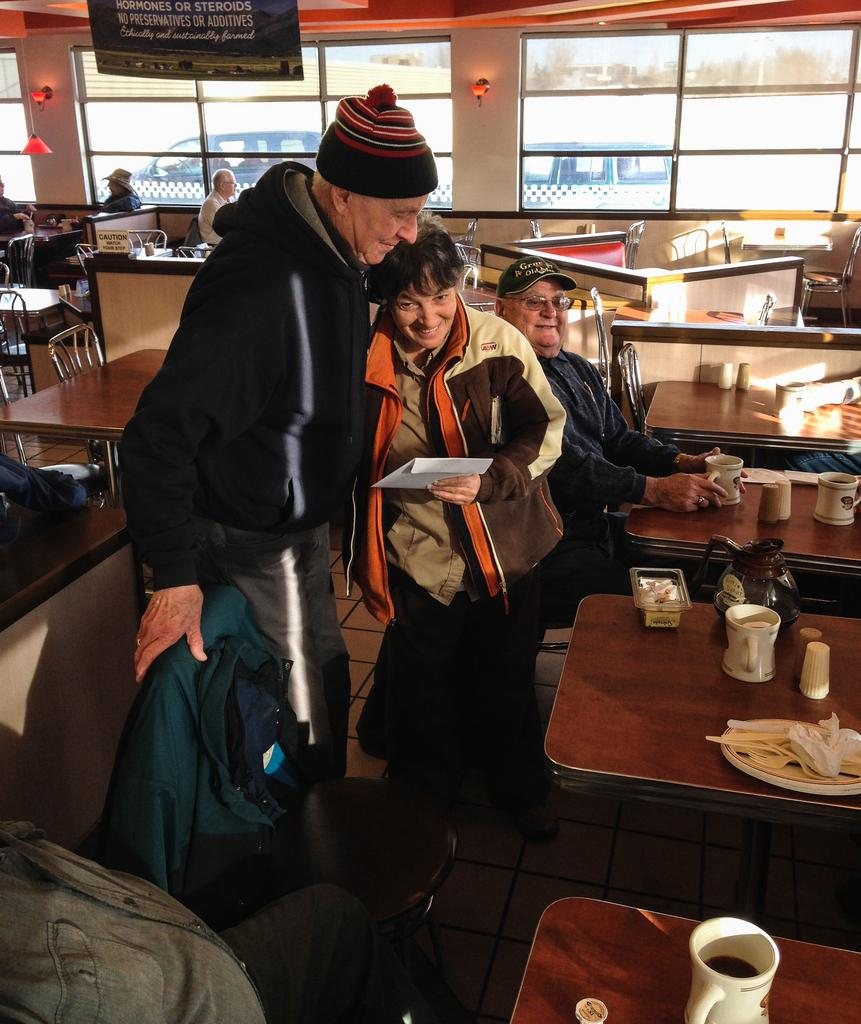How many people are standing in front of the table in the image? There are two persons standing in front of the table in the image. What is on the table in the image? The table has objects on it. Can you describe the position of the third person in the image? There is another person sitting behind the two standing persons. What can be seen in the background of the image? Cars are visible in the background. What color is the marble on the shirt of the person sitting behind the two standing persons? There is no marble or shirt present in the image. 